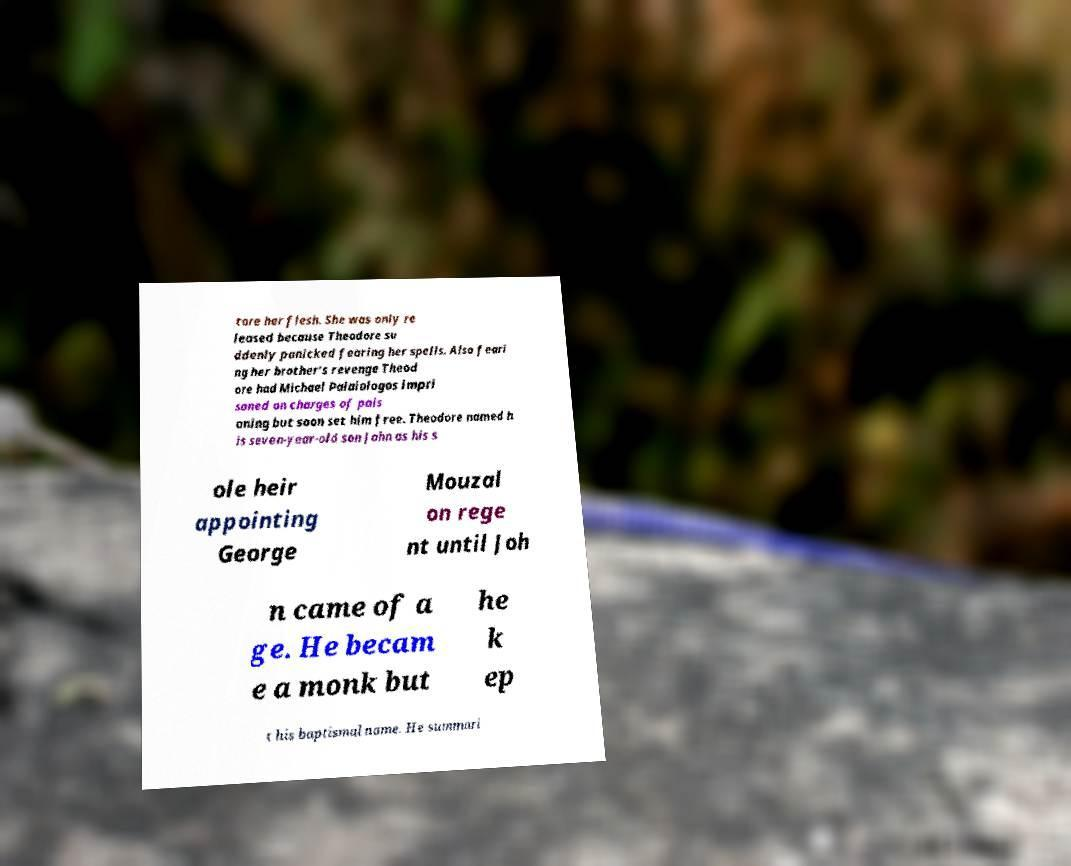There's text embedded in this image that I need extracted. Can you transcribe it verbatim? tore her flesh. She was only re leased because Theodore su ddenly panicked fearing her spells. Also feari ng her brother's revenge Theod ore had Michael Palaiologos impri soned on charges of pois oning but soon set him free. Theodore named h is seven-year-old son John as his s ole heir appointing George Mouzal on rege nt until Joh n came of a ge. He becam e a monk but he k ep t his baptismal name. He summari 